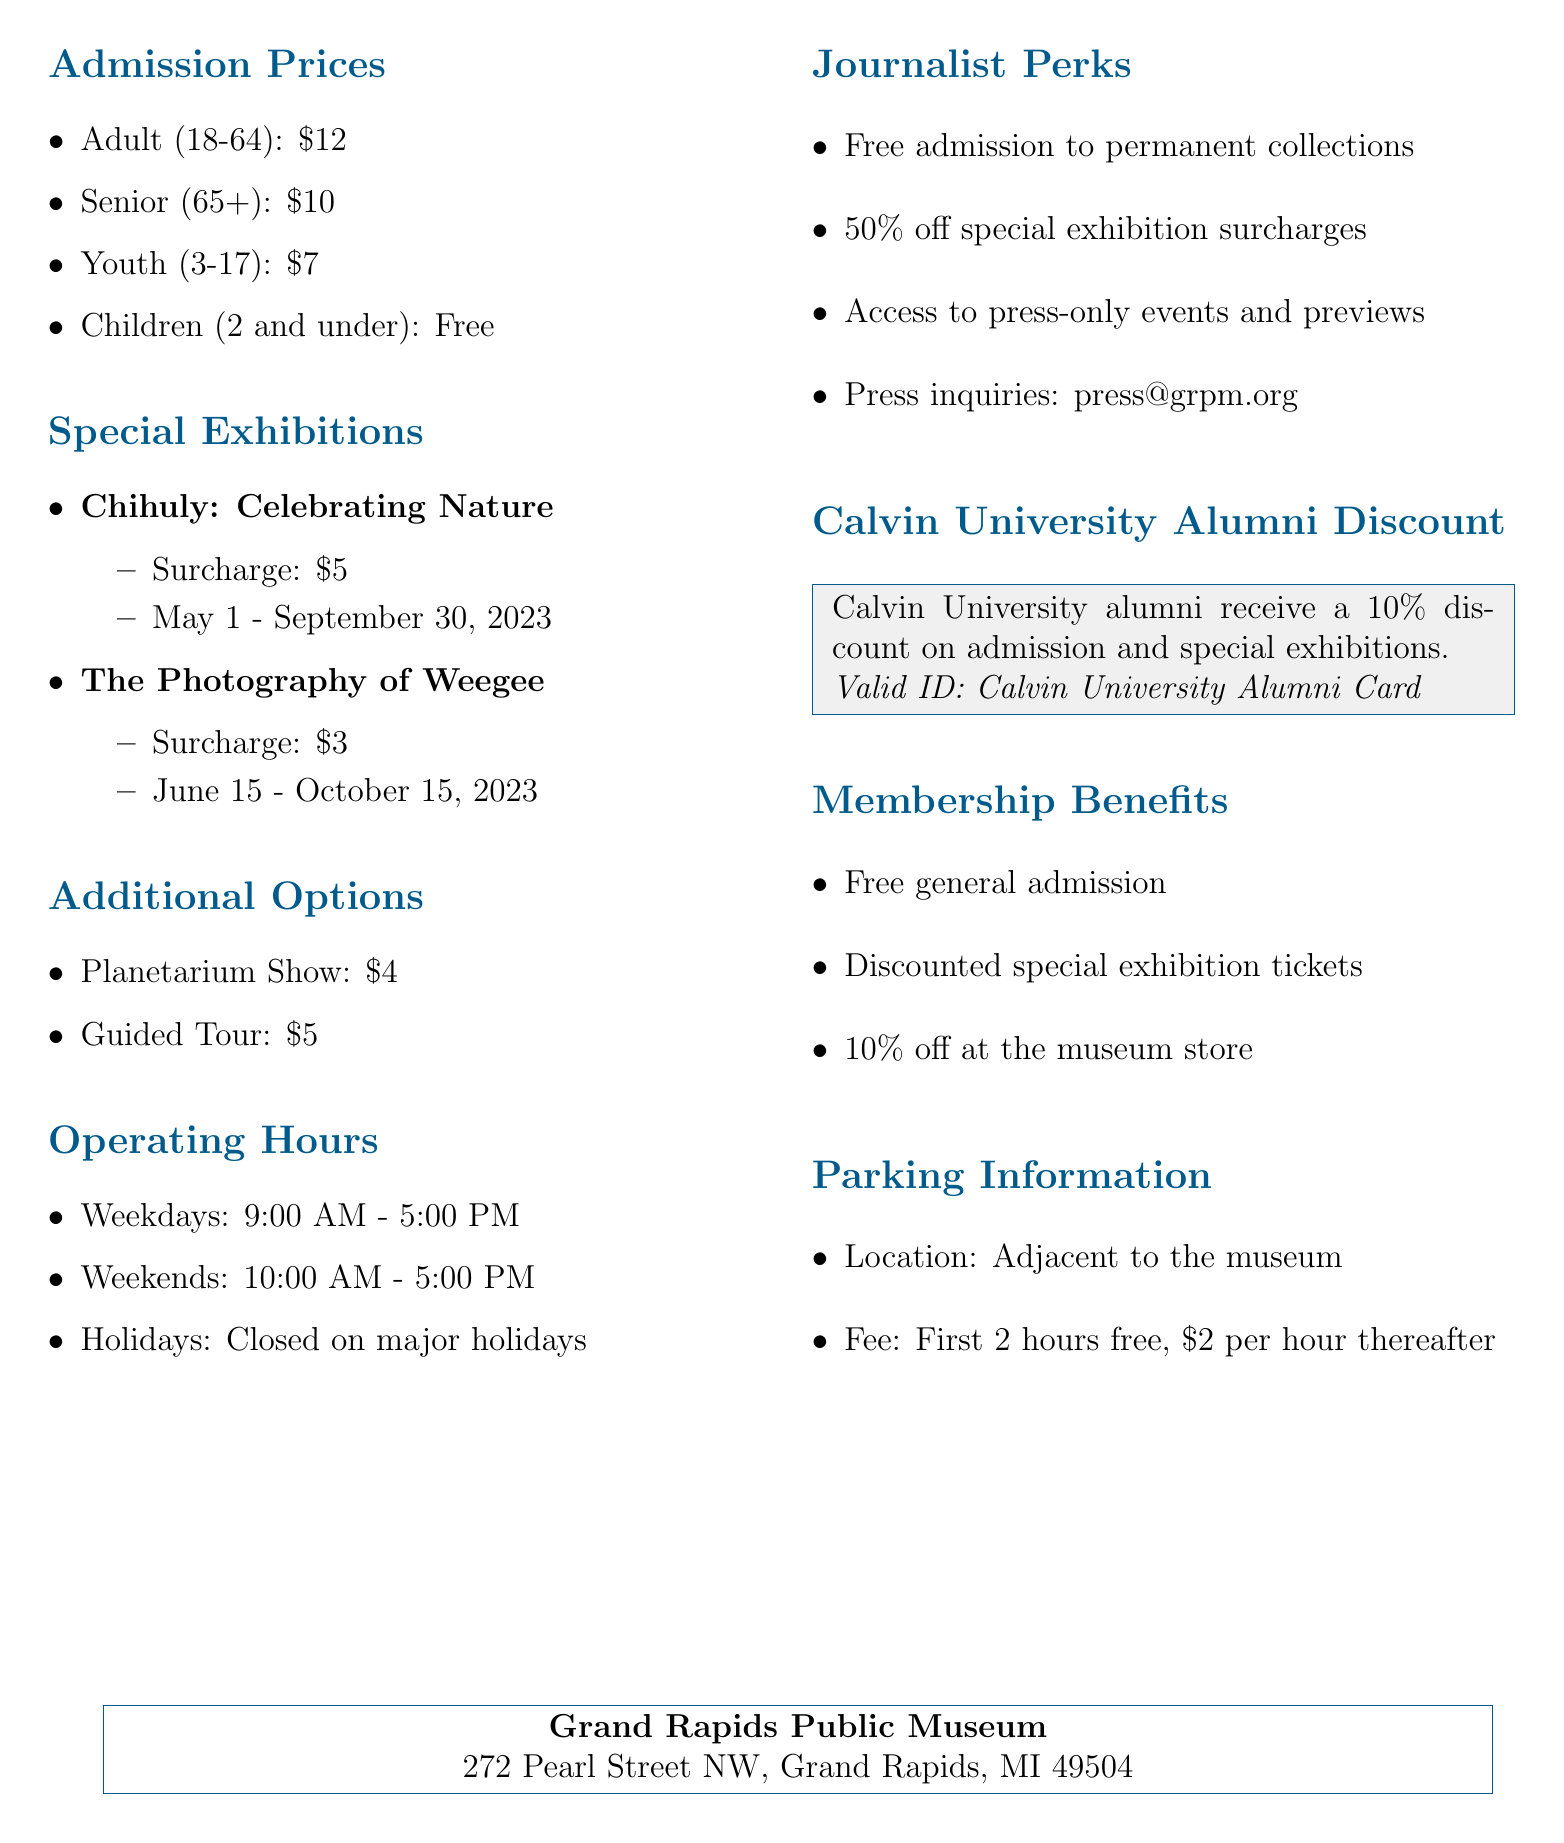what is the address of the museum? The address is provided in the document.
Answer: 272 Pearl Street NW, Grand Rapids, MI 49504 how much is the admission price for youth? The price list includes different admission categories and their respective prices.
Answer: 7 what is the surcharge for the special exhibition "Chihuly: Celebrating Nature"? The document specifies the surcharge for each special exhibition.
Answer: 5 what is the discount percentage for Calvin University alumni? The alumni discount is mentioned in the document along with its details.
Answer: 10% what are the operating hours on weekends? The document outlines the operating hours for various days.
Answer: 10:00 AM - 5:00 PM what benefits do traveling journalists receive? The document lists specific benefits for journalists, summarizing important perks.
Answer: Free admission to permanent collections how much is the surcharge for the special exhibitions? The document lists the surcharges for each special exhibition.
Answer: 5 and 3 how long does the special exhibition "The Photography of Weegee" run? The duration for special exhibitions is provided in the document.
Answer: June 15 - October 15, 2023 what is the fee for parking after the first 2 hours? The parking information details the fees after an initial period.
Answer: 2 per hour 